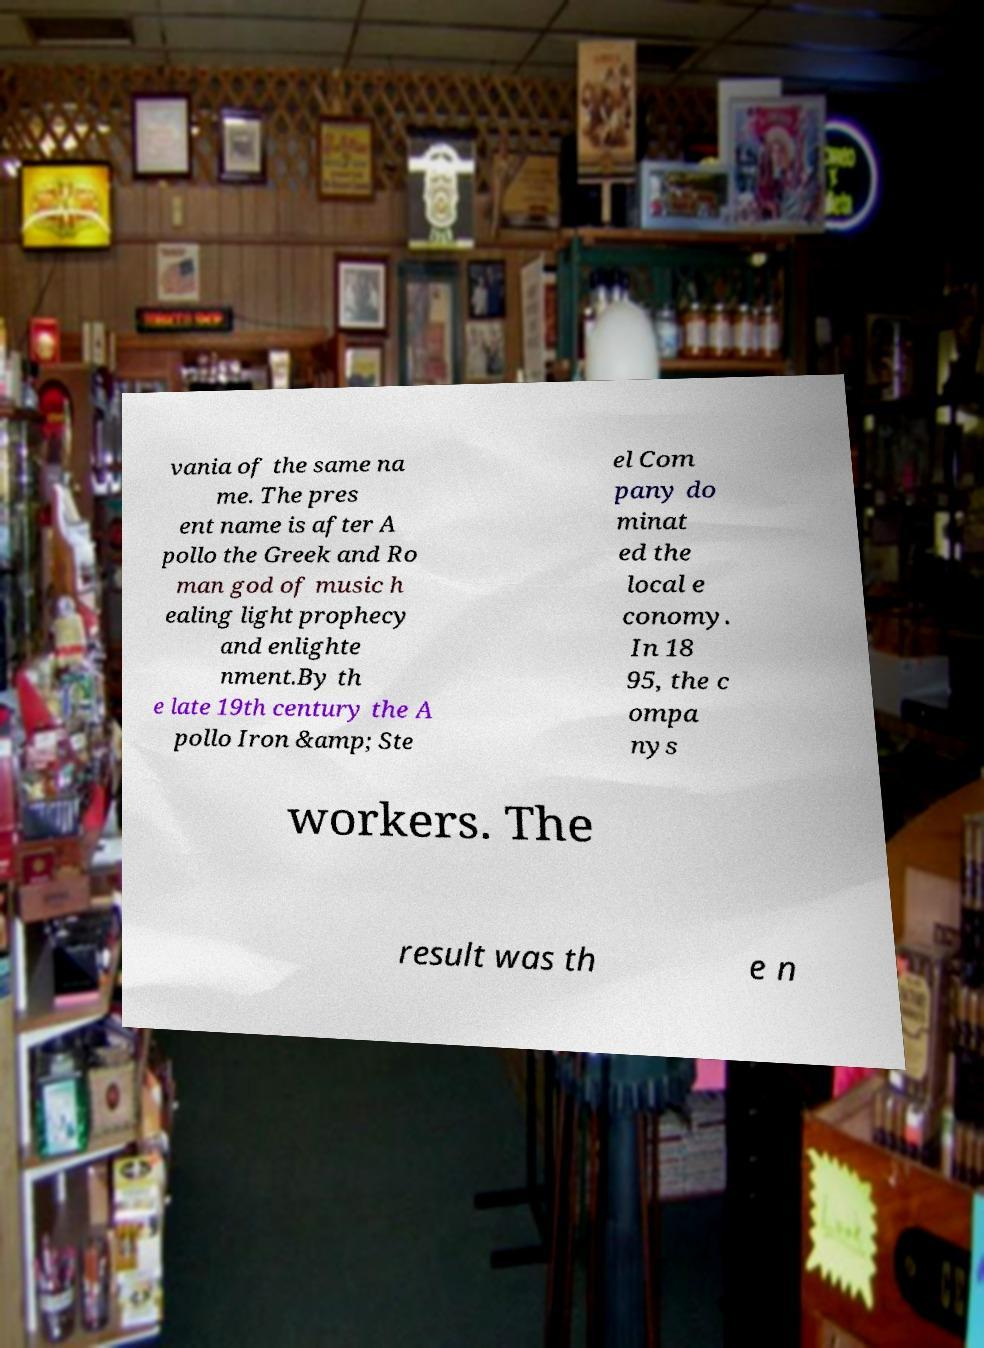Please identify and transcribe the text found in this image. vania of the same na me. The pres ent name is after A pollo the Greek and Ro man god of music h ealing light prophecy and enlighte nment.By th e late 19th century the A pollo Iron &amp; Ste el Com pany do minat ed the local e conomy. In 18 95, the c ompa nys workers. The result was th e n 